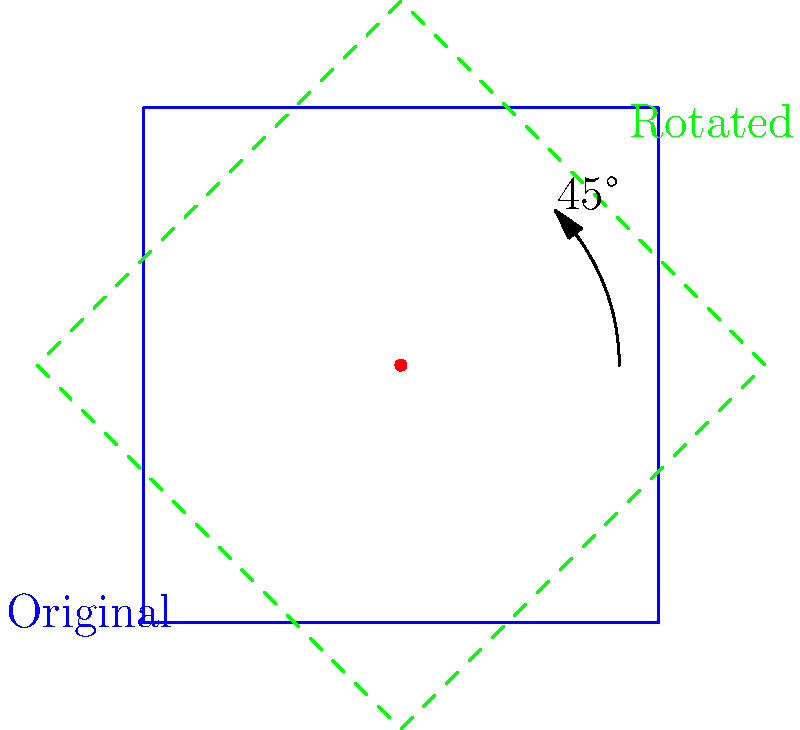In Maple Story, you want to rotate your character sprite by 45° clockwise around a fixed point. If the original sprite's top-right corner is at coordinates (1, 1), what will be the coordinates of the rotated sprite's top-right corner? Round your answer to two decimal places. To solve this problem, we'll use the rotation formula in 2D space:

$x' = x \cos \theta - y \sin \theta$
$y' = x \sin \theta + y \cos \theta$

Where $(x, y)$ are the original coordinates, $(x', y')$ are the rotated coordinates, and $\theta$ is the angle of rotation.

Steps:
1. The original coordinates are (1, 1).
2. We're rotating 45° clockwise, which is equivalent to -45° counterclockwise. So, $\theta = -45° = -\frac{\pi}{4}$ radians.
3. Calculate $\cos \theta$ and $\sin \theta$:
   $\cos (-\frac{\pi}{4}) = \frac{\sqrt{2}}{2}$
   $\sin (-\frac{\pi}{4}) = -\frac{\sqrt{2}}{2}$
4. Apply the rotation formula:
   $x' = 1 \cdot \frac{\sqrt{2}}{2} - 1 \cdot (-\frac{\sqrt{2}}{2}) = \sqrt{2}$
   $y' = 1 \cdot (-\frac{\sqrt{2}}{2}) + 1 \cdot \frac{\sqrt{2}}{2} = 0$
5. Round to two decimal places:
   $x' \approx 1.41$
   $y' = 0.00$

Therefore, the rotated sprite's top-right corner will be at approximately (1.41, 0.00).
Answer: (1.41, 0.00) 